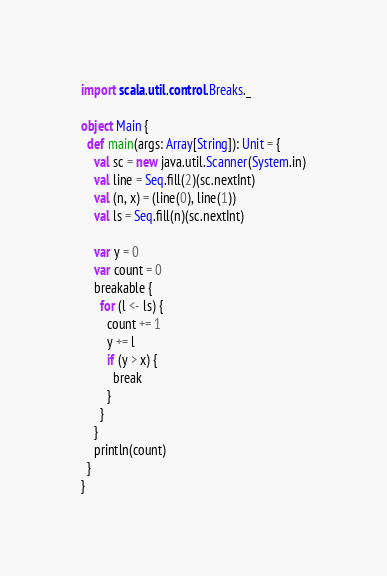<code> <loc_0><loc_0><loc_500><loc_500><_Scala_>import scala.util.control.Breaks._

object Main {
  def main(args: Array[String]): Unit = {
    val sc = new java.util.Scanner(System.in)
    val line = Seq.fill(2)(sc.nextInt)
    val (n, x) = (line(0), line(1))
    val ls = Seq.fill(n)(sc.nextInt)

    var y = 0
    var count = 0
    breakable {
      for (l <- ls) {
        count += 1
        y += l
        if (y > x) {
          break
        }
      }
    }
    println(count)
  }
}</code> 